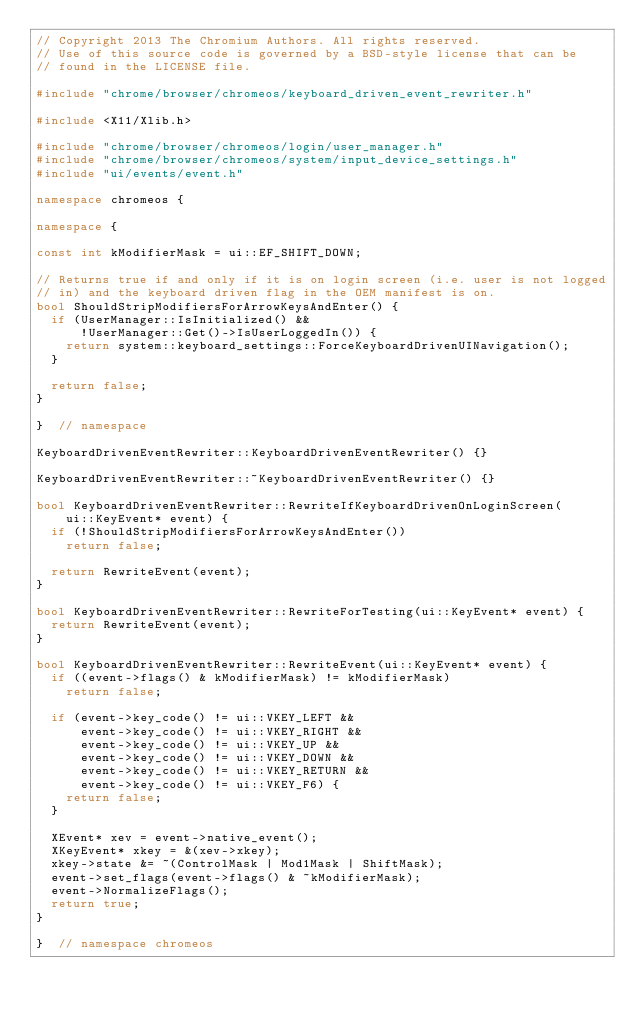Convert code to text. <code><loc_0><loc_0><loc_500><loc_500><_C++_>// Copyright 2013 The Chromium Authors. All rights reserved.
// Use of this source code is governed by a BSD-style license that can be
// found in the LICENSE file.

#include "chrome/browser/chromeos/keyboard_driven_event_rewriter.h"

#include <X11/Xlib.h>

#include "chrome/browser/chromeos/login/user_manager.h"
#include "chrome/browser/chromeos/system/input_device_settings.h"
#include "ui/events/event.h"

namespace chromeos {

namespace {

const int kModifierMask = ui::EF_SHIFT_DOWN;

// Returns true if and only if it is on login screen (i.e. user is not logged
// in) and the keyboard driven flag in the OEM manifest is on.
bool ShouldStripModifiersForArrowKeysAndEnter() {
  if (UserManager::IsInitialized() &&
      !UserManager::Get()->IsUserLoggedIn()) {
    return system::keyboard_settings::ForceKeyboardDrivenUINavigation();
  }

  return false;
}

}  // namespace

KeyboardDrivenEventRewriter::KeyboardDrivenEventRewriter() {}

KeyboardDrivenEventRewriter::~KeyboardDrivenEventRewriter() {}

bool KeyboardDrivenEventRewriter::RewriteIfKeyboardDrivenOnLoginScreen(
    ui::KeyEvent* event) {
  if (!ShouldStripModifiersForArrowKeysAndEnter())
    return false;

  return RewriteEvent(event);
}

bool KeyboardDrivenEventRewriter::RewriteForTesting(ui::KeyEvent* event) {
  return RewriteEvent(event);
}

bool KeyboardDrivenEventRewriter::RewriteEvent(ui::KeyEvent* event) {
  if ((event->flags() & kModifierMask) != kModifierMask)
    return false;

  if (event->key_code() != ui::VKEY_LEFT &&
      event->key_code() != ui::VKEY_RIGHT &&
      event->key_code() != ui::VKEY_UP &&
      event->key_code() != ui::VKEY_DOWN &&
      event->key_code() != ui::VKEY_RETURN &&
      event->key_code() != ui::VKEY_F6) {
    return false;
  }

  XEvent* xev = event->native_event();
  XKeyEvent* xkey = &(xev->xkey);
  xkey->state &= ~(ControlMask | Mod1Mask | ShiftMask);
  event->set_flags(event->flags() & ~kModifierMask);
  event->NormalizeFlags();
  return true;
}

}  // namespace chromeos
</code> 